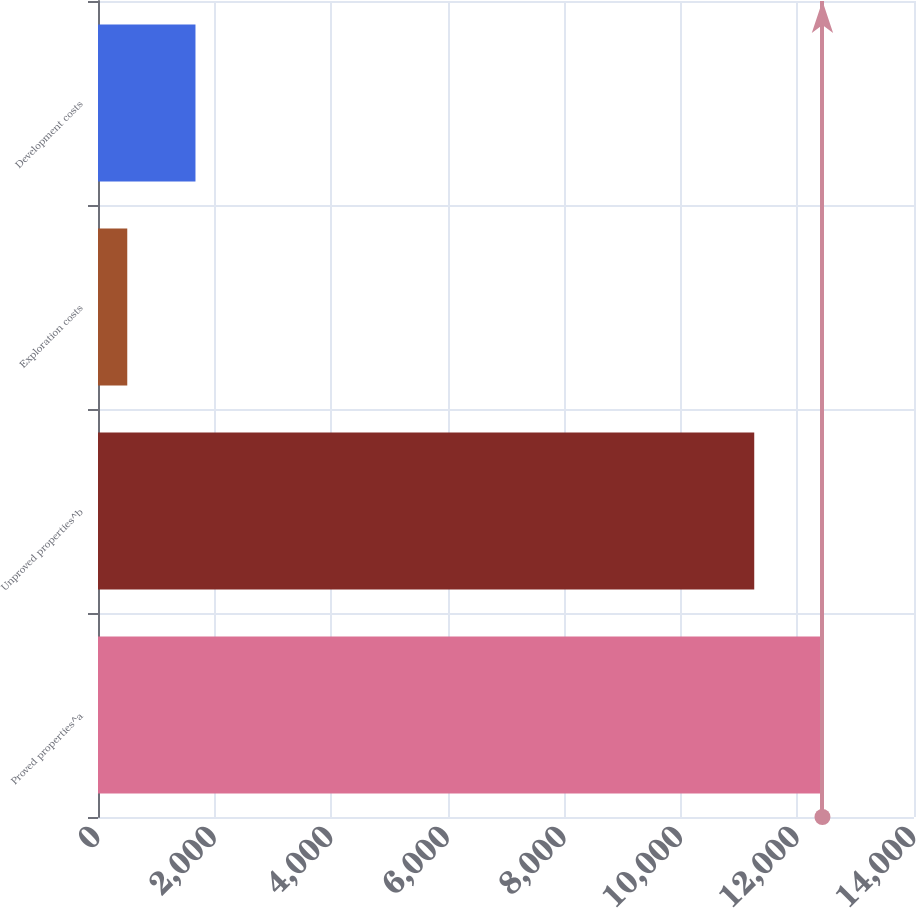<chart> <loc_0><loc_0><loc_500><loc_500><bar_chart><fcel>Proved properties^a<fcel>Unproved properties^b<fcel>Exploration costs<fcel>Development costs<nl><fcel>12429.3<fcel>11259<fcel>502<fcel>1672.3<nl></chart> 